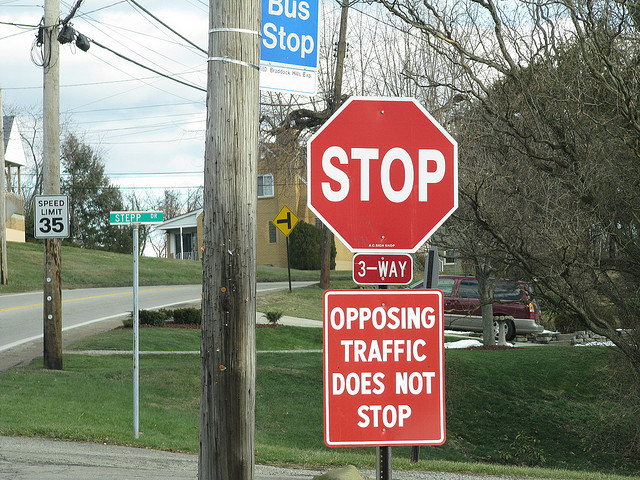Read all the text in this image. OPPOSING TRAFFIC DOES NOT STOP STOP STEPP 35 LIMIT SPEED WEAY 3 Stop Bus 